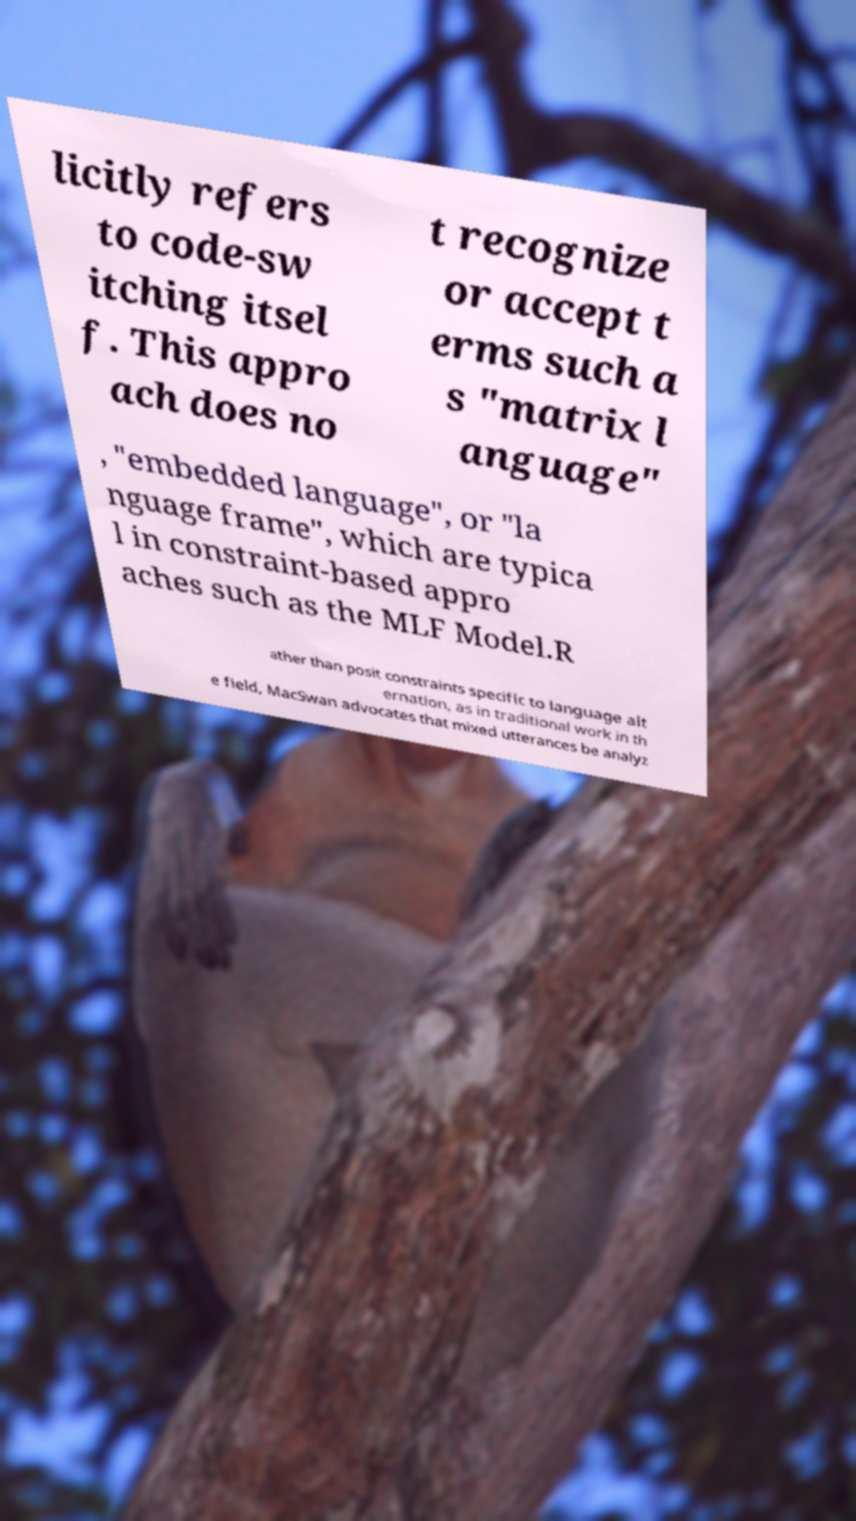What messages or text are displayed in this image? I need them in a readable, typed format. licitly refers to code-sw itching itsel f. This appro ach does no t recognize or accept t erms such a s "matrix l anguage" , "embedded language", or "la nguage frame", which are typica l in constraint-based appro aches such as the MLF Model.R ather than posit constraints specific to language alt ernation, as in traditional work in th e field, MacSwan advocates that mixed utterances be analyz 